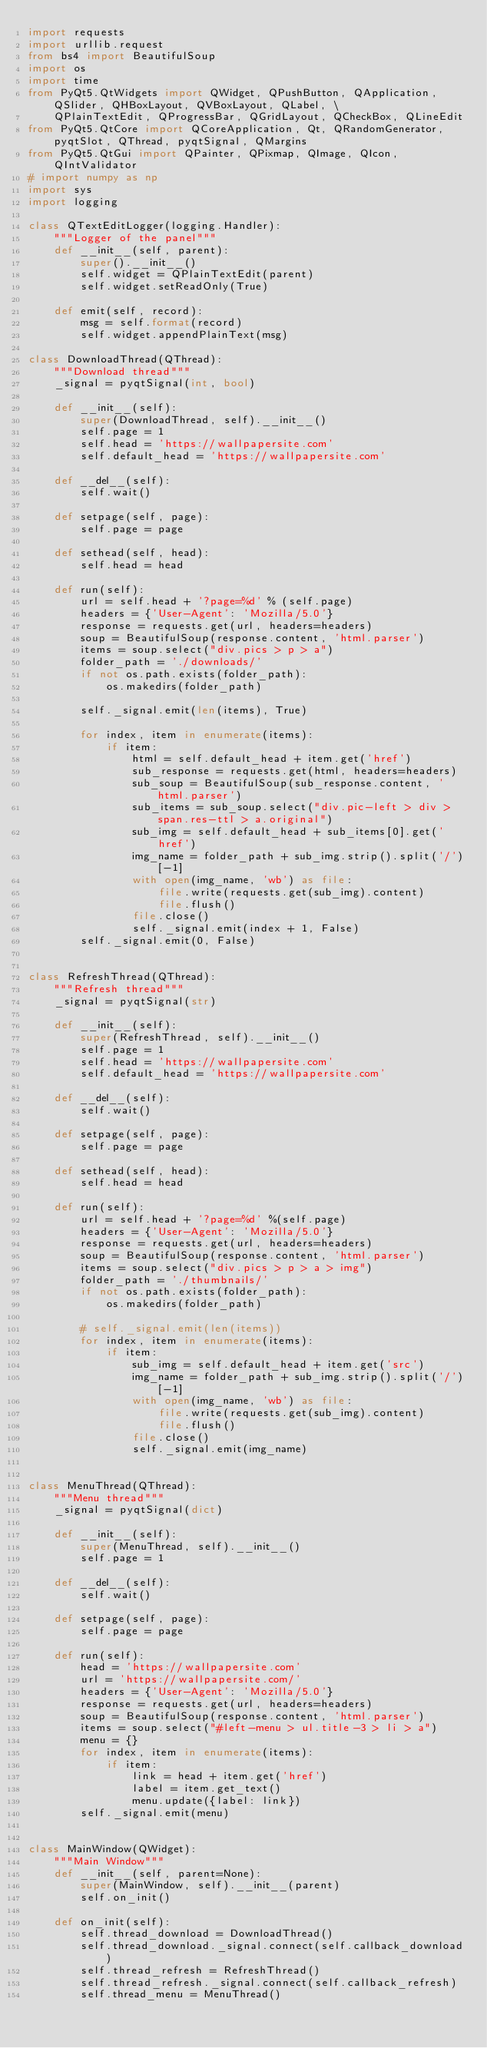<code> <loc_0><loc_0><loc_500><loc_500><_Python_>import requests
import urllib.request
from bs4 import BeautifulSoup
import os
import time
from PyQt5.QtWidgets import QWidget, QPushButton, QApplication, QSlider, QHBoxLayout, QVBoxLayout, QLabel, \
    QPlainTextEdit, QProgressBar, QGridLayout, QCheckBox, QLineEdit
from PyQt5.QtCore import QCoreApplication, Qt, QRandomGenerator, pyqtSlot, QThread, pyqtSignal, QMargins
from PyQt5.QtGui import QPainter, QPixmap, QImage, QIcon, QIntValidator
# import numpy as np
import sys
import logging

class QTextEditLogger(logging.Handler):
    """Logger of the panel"""
    def __init__(self, parent):
        super().__init__()
        self.widget = QPlainTextEdit(parent)
        self.widget.setReadOnly(True)

    def emit(self, record):
        msg = self.format(record)
        self.widget.appendPlainText(msg)
        
class DownloadThread(QThread):
    """Download thread"""
    _signal = pyqtSignal(int, bool)

    def __init__(self):
        super(DownloadThread, self).__init__()
        self.page = 1
        self.head = 'https://wallpapersite.com'
        self.default_head = 'https://wallpapersite.com'

    def __del__(self):
        self.wait()

    def setpage(self, page):
        self.page = page

    def sethead(self, head):
        self.head = head

    def run(self):
        url = self.head + '?page=%d' % (self.page)
        headers = {'User-Agent': 'Mozilla/5.0'}
        response = requests.get(url, headers=headers)
        soup = BeautifulSoup(response.content, 'html.parser')
        items = soup.select("div.pics > p > a")
        folder_path = './downloads/'
        if not os.path.exists(folder_path):
            os.makedirs(folder_path)

        self._signal.emit(len(items), True)

        for index, item in enumerate(items):
            if item:
                html = self.default_head + item.get('href')
                sub_response = requests.get(html, headers=headers)
                sub_soup = BeautifulSoup(sub_response.content, 'html.parser')
                sub_items = sub_soup.select("div.pic-left > div > span.res-ttl > a.original")
                sub_img = self.default_head + sub_items[0].get('href')
                img_name = folder_path + sub_img.strip().split('/')[-1]
                with open(img_name, 'wb') as file:
                    file.write(requests.get(sub_img).content)
                    file.flush()
                file.close()
                self._signal.emit(index + 1, False)
        self._signal.emit(0, False)


class RefreshThread(QThread):
    """Refresh thread"""
    _signal = pyqtSignal(str)

    def __init__(self):
        super(RefreshThread, self).__init__()
        self.page = 1
        self.head = 'https://wallpapersite.com'
        self.default_head = 'https://wallpapersite.com'

    def __del__(self):
        self.wait()

    def setpage(self, page):
        self.page = page
    
    def sethead(self, head):
        self.head = head

    def run(self):
        url = self.head + '?page=%d' %(self.page)
        headers = {'User-Agent': 'Mozilla/5.0'}
        response = requests.get(url, headers=headers)
        soup = BeautifulSoup(response.content, 'html.parser')
        items = soup.select("div.pics > p > a > img")
        folder_path = './thumbnails/'
        if not os.path.exists(folder_path):
            os.makedirs(folder_path)

        # self._signal.emit(len(items))
        for index, item in enumerate(items):
            if item:
                sub_img = self.default_head + item.get('src')
                img_name = folder_path + sub_img.strip().split('/')[-1]
                with open(img_name, 'wb') as file:
                    file.write(requests.get(sub_img).content)
                    file.flush()
                file.close()
                self._signal.emit(img_name)


class MenuThread(QThread):
    """Menu thread"""
    _signal = pyqtSignal(dict)

    def __init__(self):
        super(MenuThread, self).__init__()
        self.page = 1

    def __del__(self):
        self.wait()

    def setpage(self, page):
        self.page = page

    def run(self):
        head = 'https://wallpapersite.com'
        url = 'https://wallpapersite.com/'
        headers = {'User-Agent': 'Mozilla/5.0'}
        response = requests.get(url, headers=headers)
        soup = BeautifulSoup(response.content, 'html.parser')
        items = soup.select("#left-menu > ul.title-3 > li > a")
        menu = {}
        for index, item in enumerate(items):
            if item:
                link = head + item.get('href')
                label = item.get_text()
                menu.update({label: link})
        self._signal.emit(menu)


class MainWindow(QWidget):
    """Main Window"""
    def __init__(self, parent=None):
        super(MainWindow, self).__init__(parent)
        self.on_init()

    def on_init(self):
        self.thread_download = DownloadThread()
        self.thread_download._signal.connect(self.callback_download)
        self.thread_refresh = RefreshThread()
        self.thread_refresh._signal.connect(self.callback_refresh)
        self.thread_menu = MenuThread()</code> 